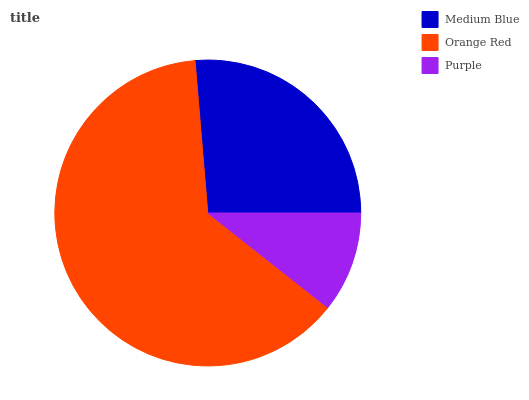Is Purple the minimum?
Answer yes or no. Yes. Is Orange Red the maximum?
Answer yes or no. Yes. Is Orange Red the minimum?
Answer yes or no. No. Is Purple the maximum?
Answer yes or no. No. Is Orange Red greater than Purple?
Answer yes or no. Yes. Is Purple less than Orange Red?
Answer yes or no. Yes. Is Purple greater than Orange Red?
Answer yes or no. No. Is Orange Red less than Purple?
Answer yes or no. No. Is Medium Blue the high median?
Answer yes or no. Yes. Is Medium Blue the low median?
Answer yes or no. Yes. Is Purple the high median?
Answer yes or no. No. Is Orange Red the low median?
Answer yes or no. No. 